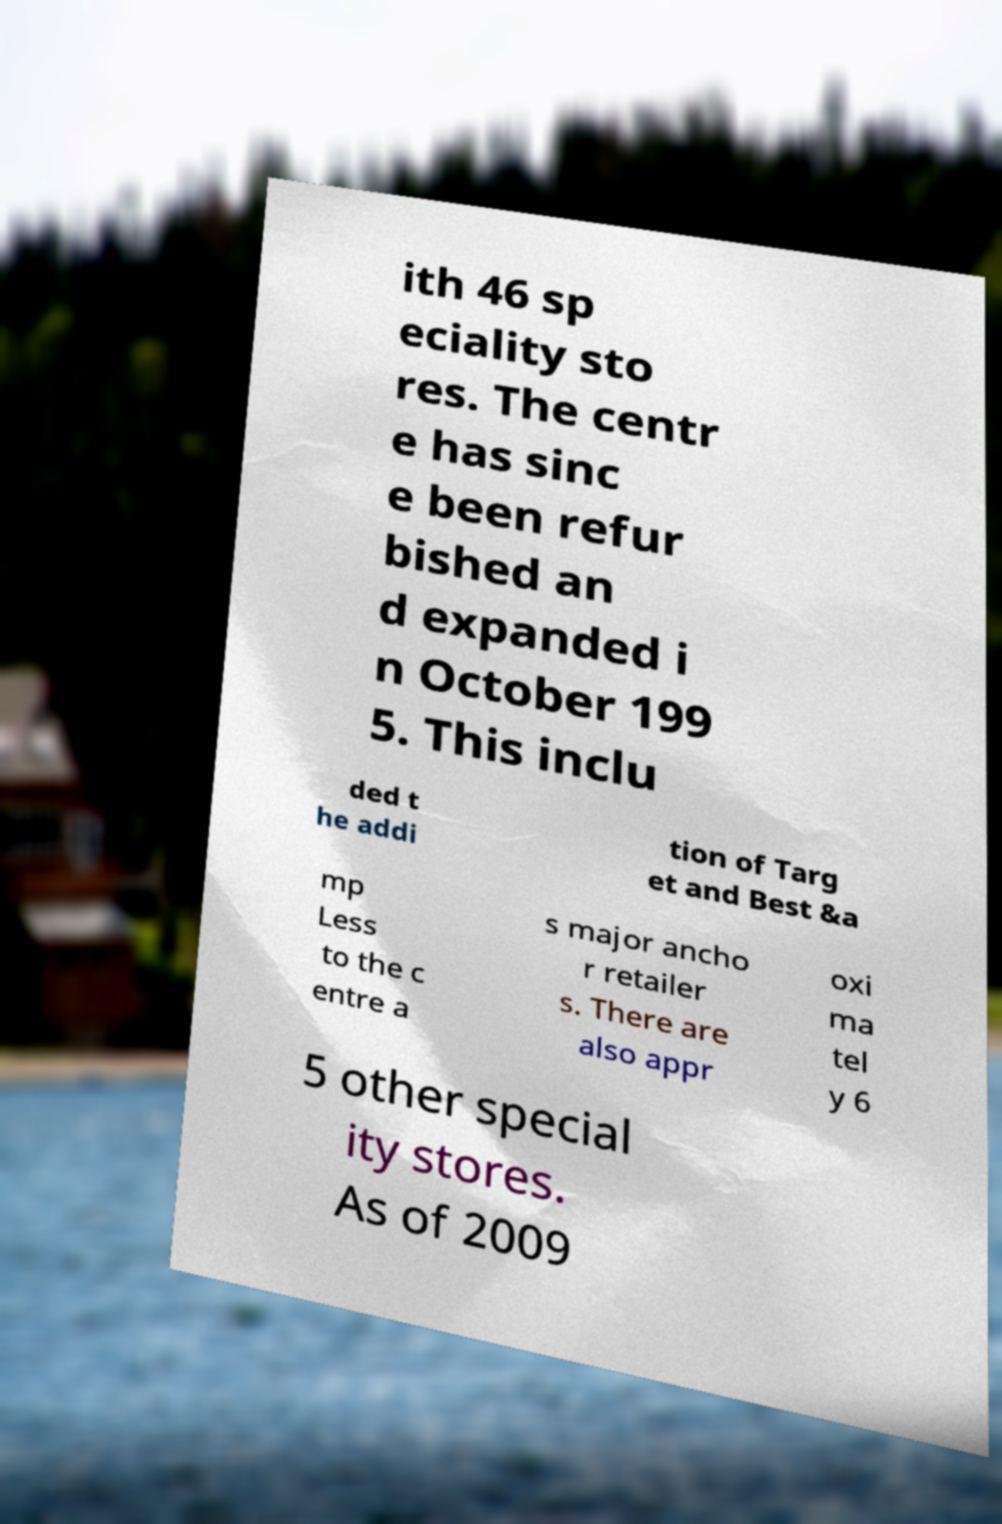For documentation purposes, I need the text within this image transcribed. Could you provide that? ith 46 sp eciality sto res. The centr e has sinc e been refur bished an d expanded i n October 199 5. This inclu ded t he addi tion of Targ et and Best &a mp Less to the c entre a s major ancho r retailer s. There are also appr oxi ma tel y 6 5 other special ity stores. As of 2009 